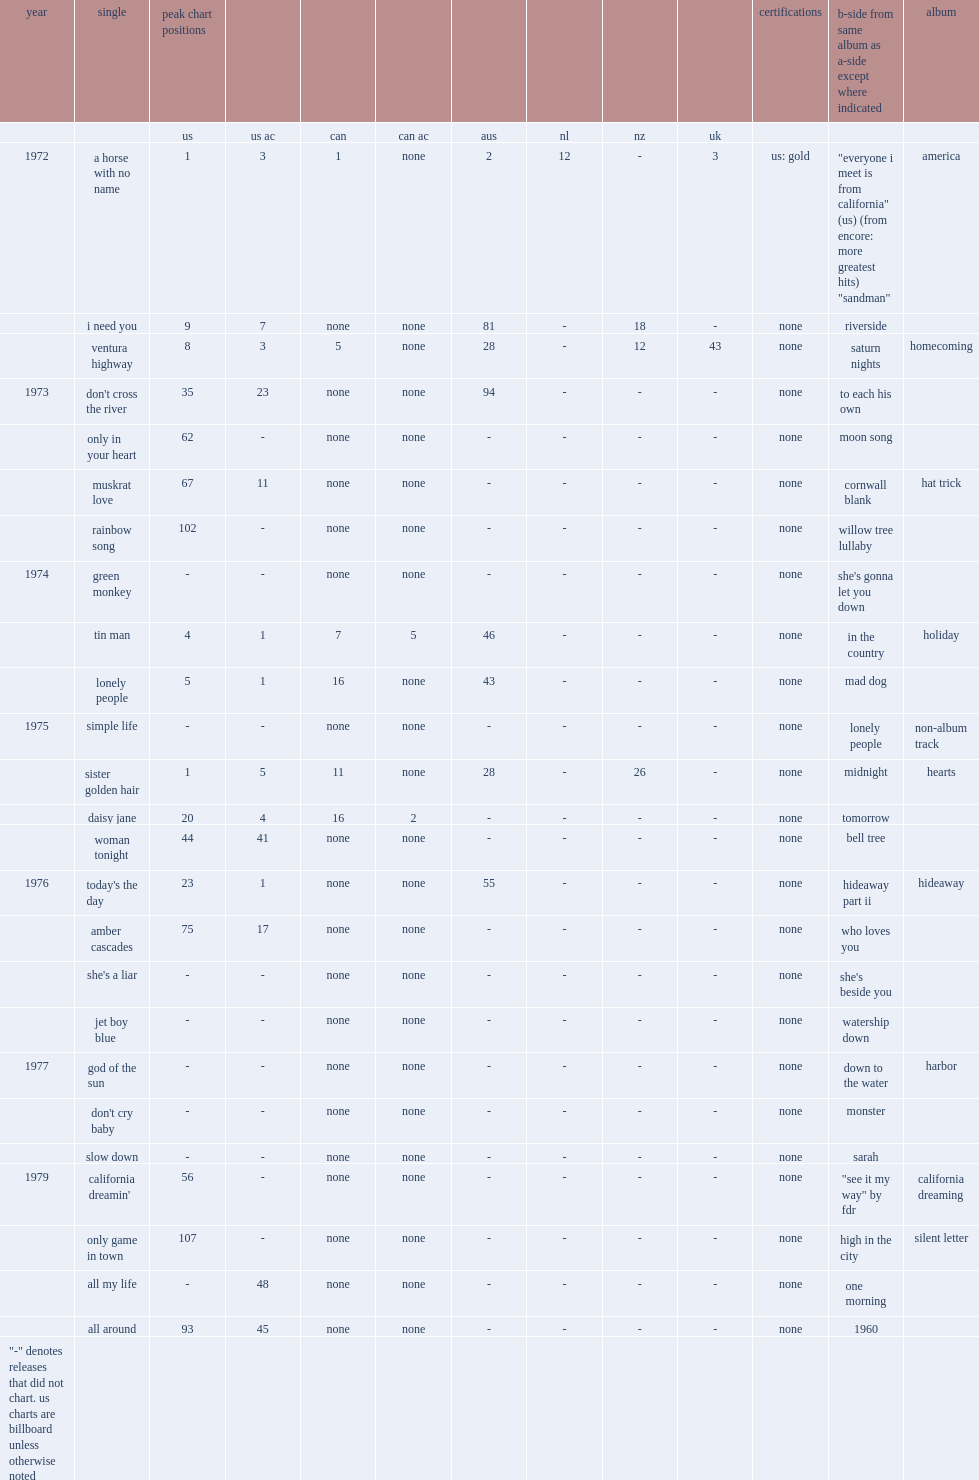When did america release "a horse with no name"? 1972.0. 